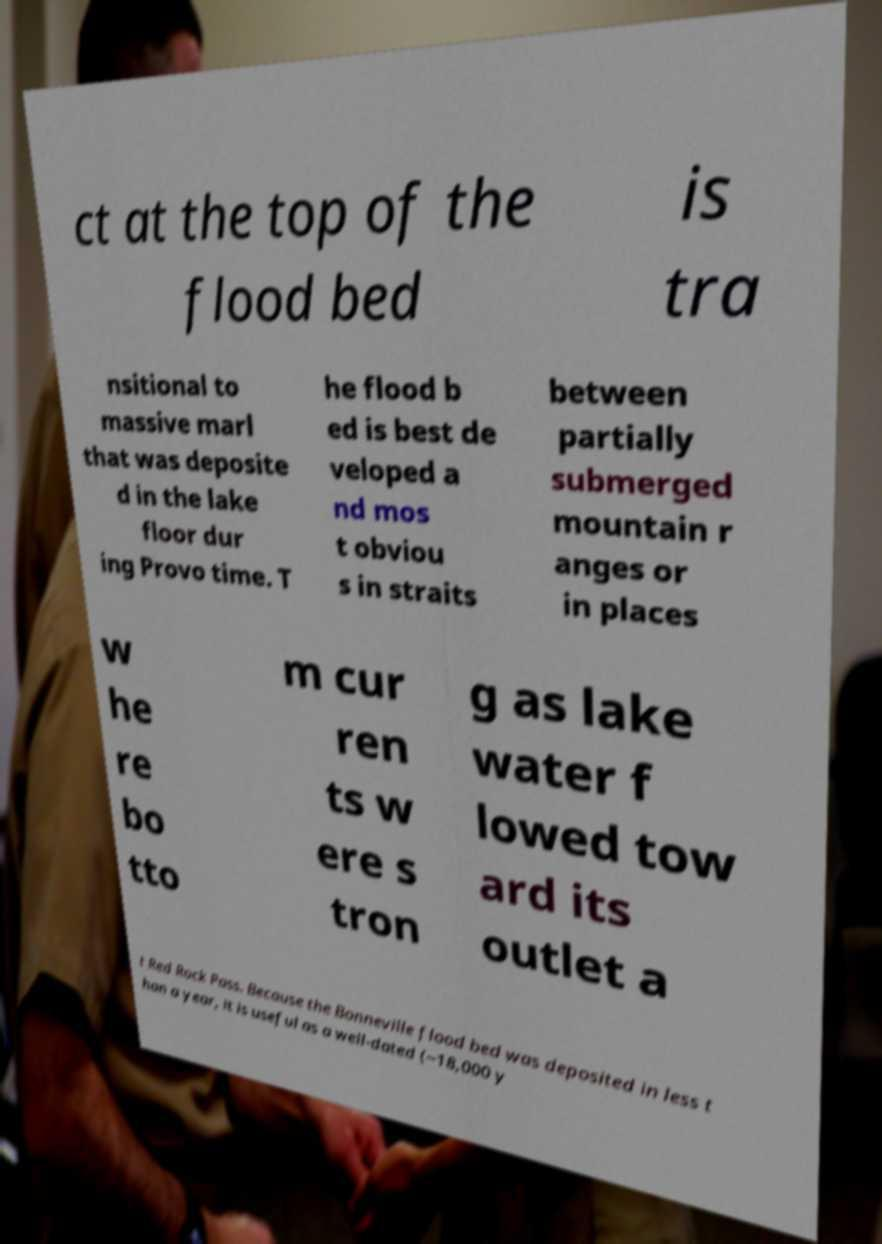Can you read and provide the text displayed in the image?This photo seems to have some interesting text. Can you extract and type it out for me? ct at the top of the flood bed is tra nsitional to massive marl that was deposite d in the lake floor dur ing Provo time. T he flood b ed is best de veloped a nd mos t obviou s in straits between partially submerged mountain r anges or in places w he re bo tto m cur ren ts w ere s tron g as lake water f lowed tow ard its outlet a t Red Rock Pass. Because the Bonneville flood bed was deposited in less t han a year, it is useful as a well-dated (~18,000 y 